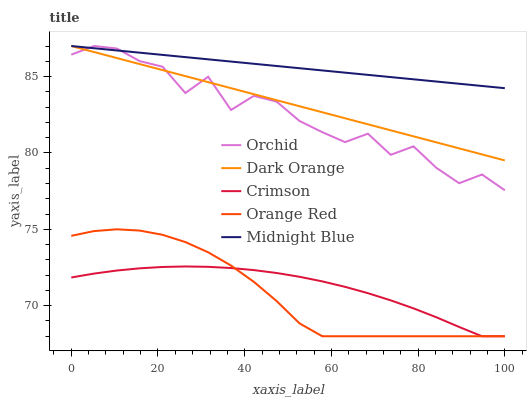Does Orange Red have the minimum area under the curve?
Answer yes or no. Yes. Does Midnight Blue have the maximum area under the curve?
Answer yes or no. Yes. Does Dark Orange have the minimum area under the curve?
Answer yes or no. No. Does Dark Orange have the maximum area under the curve?
Answer yes or no. No. Is Dark Orange the smoothest?
Answer yes or no. Yes. Is Orchid the roughest?
Answer yes or no. Yes. Is Midnight Blue the smoothest?
Answer yes or no. No. Is Midnight Blue the roughest?
Answer yes or no. No. Does Crimson have the lowest value?
Answer yes or no. Yes. Does Dark Orange have the lowest value?
Answer yes or no. No. Does Orchid have the highest value?
Answer yes or no. Yes. Does Orange Red have the highest value?
Answer yes or no. No. Is Orange Red less than Orchid?
Answer yes or no. Yes. Is Dark Orange greater than Crimson?
Answer yes or no. Yes. Does Midnight Blue intersect Orchid?
Answer yes or no. Yes. Is Midnight Blue less than Orchid?
Answer yes or no. No. Is Midnight Blue greater than Orchid?
Answer yes or no. No. Does Orange Red intersect Orchid?
Answer yes or no. No. 